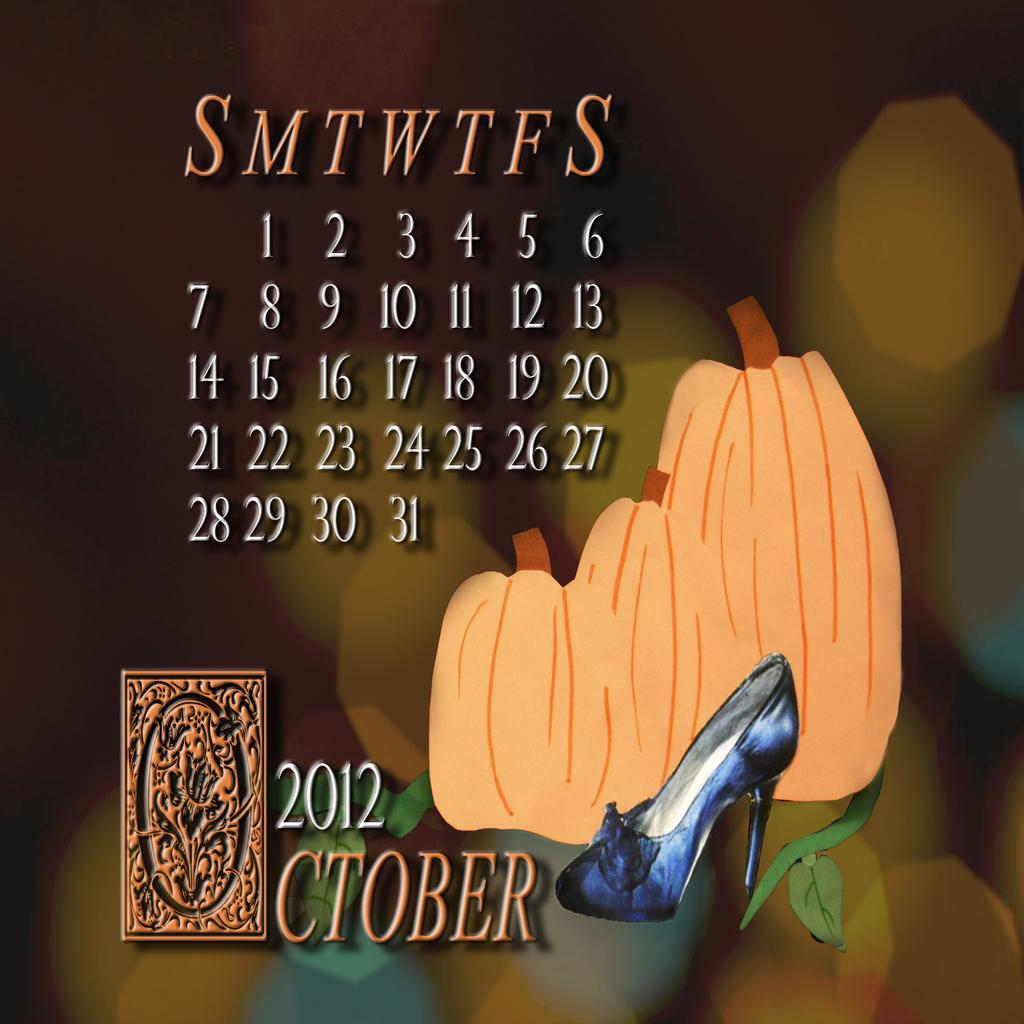What type of content is the image conveying? The image is an advertisement. What can be found within the image besides visual elements? There is text in the image. What type of objects are depicted in the paintings within the image? There is a painting of fruits and a painting of a shoe in the image. What brand or company might the image represent? There is a logo in the image, which could represent a brand or company. How would you describe the background of the image? The background of the image is blurry. Can you see any animals from the zoo in the image? There are no animals from the zoo present in the image. What type of club is featured in the image? There is no club depicted in the image. 